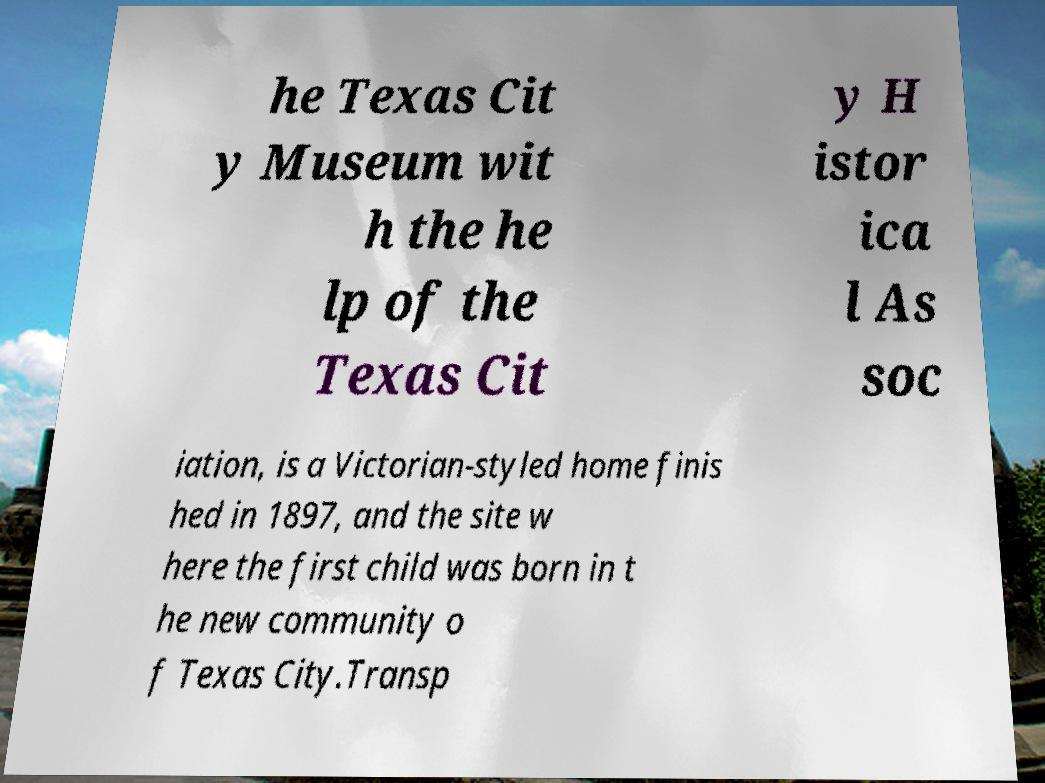For documentation purposes, I need the text within this image transcribed. Could you provide that? he Texas Cit y Museum wit h the he lp of the Texas Cit y H istor ica l As soc iation, is a Victorian-styled home finis hed in 1897, and the site w here the first child was born in t he new community o f Texas City.Transp 